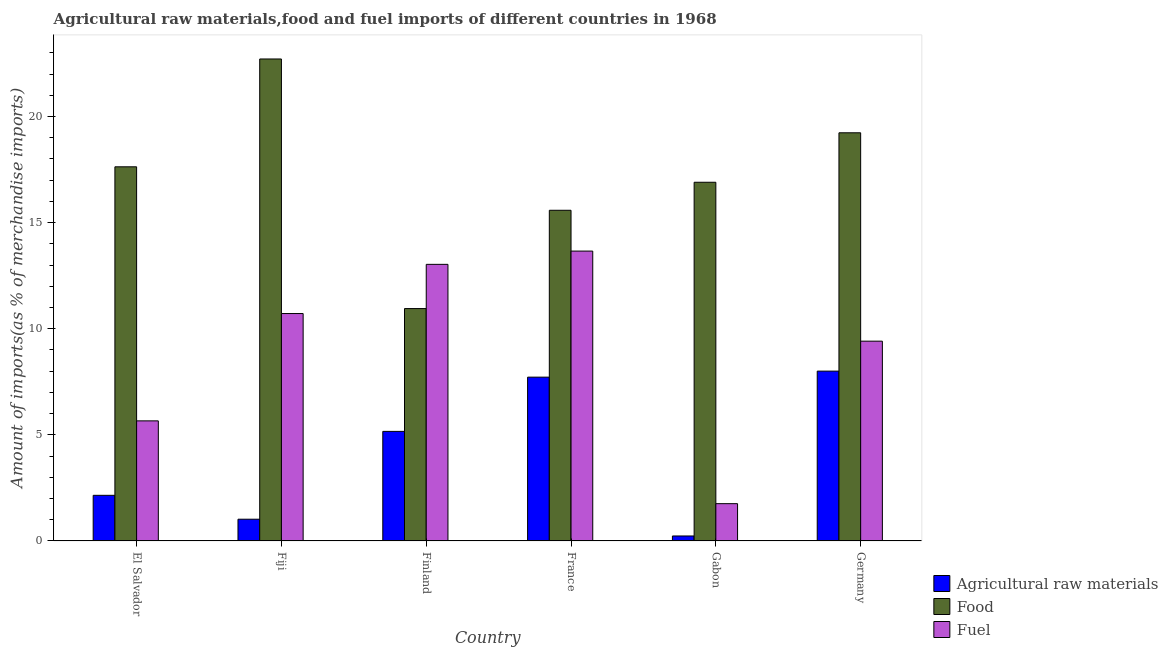How many groups of bars are there?
Offer a terse response. 6. Are the number of bars on each tick of the X-axis equal?
Your answer should be compact. Yes. What is the percentage of fuel imports in Gabon?
Give a very brief answer. 1.76. Across all countries, what is the maximum percentage of raw materials imports?
Your answer should be compact. 8. Across all countries, what is the minimum percentage of raw materials imports?
Your answer should be compact. 0.24. In which country was the percentage of raw materials imports minimum?
Give a very brief answer. Gabon. What is the total percentage of raw materials imports in the graph?
Your response must be concise. 24.3. What is the difference between the percentage of raw materials imports in Gabon and that in Germany?
Provide a succinct answer. -7.77. What is the difference between the percentage of fuel imports in Germany and the percentage of food imports in El Salvador?
Keep it short and to the point. -8.21. What is the average percentage of raw materials imports per country?
Your response must be concise. 4.05. What is the difference between the percentage of food imports and percentage of raw materials imports in France?
Your response must be concise. 7.86. What is the ratio of the percentage of food imports in France to that in Gabon?
Keep it short and to the point. 0.92. What is the difference between the highest and the second highest percentage of raw materials imports?
Your answer should be very brief. 0.28. What is the difference between the highest and the lowest percentage of raw materials imports?
Keep it short and to the point. 7.77. In how many countries, is the percentage of food imports greater than the average percentage of food imports taken over all countries?
Keep it short and to the point. 3. Is the sum of the percentage of raw materials imports in Fiji and Gabon greater than the maximum percentage of food imports across all countries?
Ensure brevity in your answer.  No. What does the 1st bar from the left in El Salvador represents?
Offer a terse response. Agricultural raw materials. What does the 1st bar from the right in Fiji represents?
Give a very brief answer. Fuel. Is it the case that in every country, the sum of the percentage of raw materials imports and percentage of food imports is greater than the percentage of fuel imports?
Your answer should be very brief. Yes. Are all the bars in the graph horizontal?
Ensure brevity in your answer.  No. What is the difference between two consecutive major ticks on the Y-axis?
Offer a terse response. 5. How are the legend labels stacked?
Your answer should be compact. Vertical. What is the title of the graph?
Your answer should be compact. Agricultural raw materials,food and fuel imports of different countries in 1968. What is the label or title of the X-axis?
Give a very brief answer. Country. What is the label or title of the Y-axis?
Your response must be concise. Amount of imports(as % of merchandise imports). What is the Amount of imports(as % of merchandise imports) of Agricultural raw materials in El Salvador?
Give a very brief answer. 2.15. What is the Amount of imports(as % of merchandise imports) in Food in El Salvador?
Give a very brief answer. 17.63. What is the Amount of imports(as % of merchandise imports) in Fuel in El Salvador?
Keep it short and to the point. 5.66. What is the Amount of imports(as % of merchandise imports) in Agricultural raw materials in Fiji?
Make the answer very short. 1.03. What is the Amount of imports(as % of merchandise imports) in Food in Fiji?
Make the answer very short. 22.71. What is the Amount of imports(as % of merchandise imports) in Fuel in Fiji?
Your answer should be compact. 10.72. What is the Amount of imports(as % of merchandise imports) of Agricultural raw materials in Finland?
Your response must be concise. 5.16. What is the Amount of imports(as % of merchandise imports) in Food in Finland?
Give a very brief answer. 10.95. What is the Amount of imports(as % of merchandise imports) in Fuel in Finland?
Your response must be concise. 13.03. What is the Amount of imports(as % of merchandise imports) of Agricultural raw materials in France?
Provide a short and direct response. 7.72. What is the Amount of imports(as % of merchandise imports) of Food in France?
Give a very brief answer. 15.58. What is the Amount of imports(as % of merchandise imports) of Fuel in France?
Offer a terse response. 13.66. What is the Amount of imports(as % of merchandise imports) of Agricultural raw materials in Gabon?
Your answer should be very brief. 0.24. What is the Amount of imports(as % of merchandise imports) in Food in Gabon?
Provide a succinct answer. 16.9. What is the Amount of imports(as % of merchandise imports) of Fuel in Gabon?
Offer a terse response. 1.76. What is the Amount of imports(as % of merchandise imports) of Agricultural raw materials in Germany?
Make the answer very short. 8. What is the Amount of imports(as % of merchandise imports) of Food in Germany?
Ensure brevity in your answer.  19.23. What is the Amount of imports(as % of merchandise imports) of Fuel in Germany?
Make the answer very short. 9.41. Across all countries, what is the maximum Amount of imports(as % of merchandise imports) in Agricultural raw materials?
Keep it short and to the point. 8. Across all countries, what is the maximum Amount of imports(as % of merchandise imports) of Food?
Provide a succinct answer. 22.71. Across all countries, what is the maximum Amount of imports(as % of merchandise imports) in Fuel?
Make the answer very short. 13.66. Across all countries, what is the minimum Amount of imports(as % of merchandise imports) in Agricultural raw materials?
Your answer should be very brief. 0.24. Across all countries, what is the minimum Amount of imports(as % of merchandise imports) of Food?
Your response must be concise. 10.95. Across all countries, what is the minimum Amount of imports(as % of merchandise imports) of Fuel?
Provide a succinct answer. 1.76. What is the total Amount of imports(as % of merchandise imports) of Agricultural raw materials in the graph?
Provide a short and direct response. 24.3. What is the total Amount of imports(as % of merchandise imports) of Food in the graph?
Your answer should be very brief. 103. What is the total Amount of imports(as % of merchandise imports) of Fuel in the graph?
Offer a terse response. 54.24. What is the difference between the Amount of imports(as % of merchandise imports) of Agricultural raw materials in El Salvador and that in Fiji?
Provide a short and direct response. 1.13. What is the difference between the Amount of imports(as % of merchandise imports) in Food in El Salvador and that in Fiji?
Give a very brief answer. -5.08. What is the difference between the Amount of imports(as % of merchandise imports) in Fuel in El Salvador and that in Fiji?
Your answer should be compact. -5.06. What is the difference between the Amount of imports(as % of merchandise imports) of Agricultural raw materials in El Salvador and that in Finland?
Your response must be concise. -3.01. What is the difference between the Amount of imports(as % of merchandise imports) of Food in El Salvador and that in Finland?
Your answer should be compact. 6.68. What is the difference between the Amount of imports(as % of merchandise imports) of Fuel in El Salvador and that in Finland?
Make the answer very short. -7.37. What is the difference between the Amount of imports(as % of merchandise imports) in Agricultural raw materials in El Salvador and that in France?
Give a very brief answer. -5.57. What is the difference between the Amount of imports(as % of merchandise imports) in Food in El Salvador and that in France?
Make the answer very short. 2.05. What is the difference between the Amount of imports(as % of merchandise imports) of Fuel in El Salvador and that in France?
Make the answer very short. -8. What is the difference between the Amount of imports(as % of merchandise imports) in Agricultural raw materials in El Salvador and that in Gabon?
Give a very brief answer. 1.92. What is the difference between the Amount of imports(as % of merchandise imports) in Food in El Salvador and that in Gabon?
Make the answer very short. 0.73. What is the difference between the Amount of imports(as % of merchandise imports) in Fuel in El Salvador and that in Gabon?
Provide a short and direct response. 3.9. What is the difference between the Amount of imports(as % of merchandise imports) in Agricultural raw materials in El Salvador and that in Germany?
Ensure brevity in your answer.  -5.85. What is the difference between the Amount of imports(as % of merchandise imports) of Food in El Salvador and that in Germany?
Your response must be concise. -1.6. What is the difference between the Amount of imports(as % of merchandise imports) of Fuel in El Salvador and that in Germany?
Offer a terse response. -3.76. What is the difference between the Amount of imports(as % of merchandise imports) of Agricultural raw materials in Fiji and that in Finland?
Offer a very short reply. -4.14. What is the difference between the Amount of imports(as % of merchandise imports) in Food in Fiji and that in Finland?
Offer a terse response. 11.76. What is the difference between the Amount of imports(as % of merchandise imports) of Fuel in Fiji and that in Finland?
Provide a succinct answer. -2.32. What is the difference between the Amount of imports(as % of merchandise imports) of Agricultural raw materials in Fiji and that in France?
Make the answer very short. -6.69. What is the difference between the Amount of imports(as % of merchandise imports) in Food in Fiji and that in France?
Provide a succinct answer. 7.13. What is the difference between the Amount of imports(as % of merchandise imports) of Fuel in Fiji and that in France?
Give a very brief answer. -2.94. What is the difference between the Amount of imports(as % of merchandise imports) of Agricultural raw materials in Fiji and that in Gabon?
Your answer should be compact. 0.79. What is the difference between the Amount of imports(as % of merchandise imports) of Food in Fiji and that in Gabon?
Provide a succinct answer. 5.81. What is the difference between the Amount of imports(as % of merchandise imports) in Fuel in Fiji and that in Gabon?
Offer a very short reply. 8.96. What is the difference between the Amount of imports(as % of merchandise imports) of Agricultural raw materials in Fiji and that in Germany?
Make the answer very short. -6.98. What is the difference between the Amount of imports(as % of merchandise imports) of Food in Fiji and that in Germany?
Your answer should be compact. 3.48. What is the difference between the Amount of imports(as % of merchandise imports) in Fuel in Fiji and that in Germany?
Your response must be concise. 1.3. What is the difference between the Amount of imports(as % of merchandise imports) of Agricultural raw materials in Finland and that in France?
Your response must be concise. -2.56. What is the difference between the Amount of imports(as % of merchandise imports) of Food in Finland and that in France?
Ensure brevity in your answer.  -4.63. What is the difference between the Amount of imports(as % of merchandise imports) of Fuel in Finland and that in France?
Provide a succinct answer. -0.62. What is the difference between the Amount of imports(as % of merchandise imports) of Agricultural raw materials in Finland and that in Gabon?
Offer a very short reply. 4.93. What is the difference between the Amount of imports(as % of merchandise imports) of Food in Finland and that in Gabon?
Provide a short and direct response. -5.95. What is the difference between the Amount of imports(as % of merchandise imports) in Fuel in Finland and that in Gabon?
Give a very brief answer. 11.28. What is the difference between the Amount of imports(as % of merchandise imports) of Agricultural raw materials in Finland and that in Germany?
Provide a short and direct response. -2.84. What is the difference between the Amount of imports(as % of merchandise imports) of Food in Finland and that in Germany?
Keep it short and to the point. -8.28. What is the difference between the Amount of imports(as % of merchandise imports) in Fuel in Finland and that in Germany?
Give a very brief answer. 3.62. What is the difference between the Amount of imports(as % of merchandise imports) of Agricultural raw materials in France and that in Gabon?
Make the answer very short. 7.48. What is the difference between the Amount of imports(as % of merchandise imports) of Food in France and that in Gabon?
Your answer should be compact. -1.32. What is the difference between the Amount of imports(as % of merchandise imports) of Agricultural raw materials in France and that in Germany?
Give a very brief answer. -0.28. What is the difference between the Amount of imports(as % of merchandise imports) in Food in France and that in Germany?
Your response must be concise. -3.65. What is the difference between the Amount of imports(as % of merchandise imports) in Fuel in France and that in Germany?
Ensure brevity in your answer.  4.24. What is the difference between the Amount of imports(as % of merchandise imports) of Agricultural raw materials in Gabon and that in Germany?
Provide a succinct answer. -7.77. What is the difference between the Amount of imports(as % of merchandise imports) of Food in Gabon and that in Germany?
Make the answer very short. -2.33. What is the difference between the Amount of imports(as % of merchandise imports) in Fuel in Gabon and that in Germany?
Your response must be concise. -7.66. What is the difference between the Amount of imports(as % of merchandise imports) in Agricultural raw materials in El Salvador and the Amount of imports(as % of merchandise imports) in Food in Fiji?
Give a very brief answer. -20.56. What is the difference between the Amount of imports(as % of merchandise imports) in Agricultural raw materials in El Salvador and the Amount of imports(as % of merchandise imports) in Fuel in Fiji?
Your answer should be compact. -8.56. What is the difference between the Amount of imports(as % of merchandise imports) in Food in El Salvador and the Amount of imports(as % of merchandise imports) in Fuel in Fiji?
Offer a very short reply. 6.91. What is the difference between the Amount of imports(as % of merchandise imports) in Agricultural raw materials in El Salvador and the Amount of imports(as % of merchandise imports) in Food in Finland?
Offer a terse response. -8.8. What is the difference between the Amount of imports(as % of merchandise imports) in Agricultural raw materials in El Salvador and the Amount of imports(as % of merchandise imports) in Fuel in Finland?
Make the answer very short. -10.88. What is the difference between the Amount of imports(as % of merchandise imports) in Food in El Salvador and the Amount of imports(as % of merchandise imports) in Fuel in Finland?
Your answer should be very brief. 4.6. What is the difference between the Amount of imports(as % of merchandise imports) in Agricultural raw materials in El Salvador and the Amount of imports(as % of merchandise imports) in Food in France?
Provide a short and direct response. -13.43. What is the difference between the Amount of imports(as % of merchandise imports) in Agricultural raw materials in El Salvador and the Amount of imports(as % of merchandise imports) in Fuel in France?
Ensure brevity in your answer.  -11.51. What is the difference between the Amount of imports(as % of merchandise imports) in Food in El Salvador and the Amount of imports(as % of merchandise imports) in Fuel in France?
Offer a very short reply. 3.97. What is the difference between the Amount of imports(as % of merchandise imports) in Agricultural raw materials in El Salvador and the Amount of imports(as % of merchandise imports) in Food in Gabon?
Make the answer very short. -14.75. What is the difference between the Amount of imports(as % of merchandise imports) in Agricultural raw materials in El Salvador and the Amount of imports(as % of merchandise imports) in Fuel in Gabon?
Provide a short and direct response. 0.39. What is the difference between the Amount of imports(as % of merchandise imports) of Food in El Salvador and the Amount of imports(as % of merchandise imports) of Fuel in Gabon?
Provide a short and direct response. 15.87. What is the difference between the Amount of imports(as % of merchandise imports) of Agricultural raw materials in El Salvador and the Amount of imports(as % of merchandise imports) of Food in Germany?
Provide a succinct answer. -17.08. What is the difference between the Amount of imports(as % of merchandise imports) in Agricultural raw materials in El Salvador and the Amount of imports(as % of merchandise imports) in Fuel in Germany?
Make the answer very short. -7.26. What is the difference between the Amount of imports(as % of merchandise imports) in Food in El Salvador and the Amount of imports(as % of merchandise imports) in Fuel in Germany?
Your answer should be very brief. 8.21. What is the difference between the Amount of imports(as % of merchandise imports) of Agricultural raw materials in Fiji and the Amount of imports(as % of merchandise imports) of Food in Finland?
Keep it short and to the point. -9.92. What is the difference between the Amount of imports(as % of merchandise imports) in Agricultural raw materials in Fiji and the Amount of imports(as % of merchandise imports) in Fuel in Finland?
Your answer should be very brief. -12.01. What is the difference between the Amount of imports(as % of merchandise imports) of Food in Fiji and the Amount of imports(as % of merchandise imports) of Fuel in Finland?
Give a very brief answer. 9.68. What is the difference between the Amount of imports(as % of merchandise imports) of Agricultural raw materials in Fiji and the Amount of imports(as % of merchandise imports) of Food in France?
Provide a succinct answer. -14.55. What is the difference between the Amount of imports(as % of merchandise imports) of Agricultural raw materials in Fiji and the Amount of imports(as % of merchandise imports) of Fuel in France?
Make the answer very short. -12.63. What is the difference between the Amount of imports(as % of merchandise imports) of Food in Fiji and the Amount of imports(as % of merchandise imports) of Fuel in France?
Give a very brief answer. 9.05. What is the difference between the Amount of imports(as % of merchandise imports) of Agricultural raw materials in Fiji and the Amount of imports(as % of merchandise imports) of Food in Gabon?
Give a very brief answer. -15.87. What is the difference between the Amount of imports(as % of merchandise imports) of Agricultural raw materials in Fiji and the Amount of imports(as % of merchandise imports) of Fuel in Gabon?
Keep it short and to the point. -0.73. What is the difference between the Amount of imports(as % of merchandise imports) in Food in Fiji and the Amount of imports(as % of merchandise imports) in Fuel in Gabon?
Offer a terse response. 20.95. What is the difference between the Amount of imports(as % of merchandise imports) of Agricultural raw materials in Fiji and the Amount of imports(as % of merchandise imports) of Food in Germany?
Your answer should be compact. -18.21. What is the difference between the Amount of imports(as % of merchandise imports) in Agricultural raw materials in Fiji and the Amount of imports(as % of merchandise imports) in Fuel in Germany?
Offer a very short reply. -8.39. What is the difference between the Amount of imports(as % of merchandise imports) in Food in Fiji and the Amount of imports(as % of merchandise imports) in Fuel in Germany?
Ensure brevity in your answer.  13.3. What is the difference between the Amount of imports(as % of merchandise imports) in Agricultural raw materials in Finland and the Amount of imports(as % of merchandise imports) in Food in France?
Your answer should be compact. -10.42. What is the difference between the Amount of imports(as % of merchandise imports) in Agricultural raw materials in Finland and the Amount of imports(as % of merchandise imports) in Fuel in France?
Ensure brevity in your answer.  -8.49. What is the difference between the Amount of imports(as % of merchandise imports) in Food in Finland and the Amount of imports(as % of merchandise imports) in Fuel in France?
Provide a succinct answer. -2.71. What is the difference between the Amount of imports(as % of merchandise imports) in Agricultural raw materials in Finland and the Amount of imports(as % of merchandise imports) in Food in Gabon?
Your answer should be very brief. -11.74. What is the difference between the Amount of imports(as % of merchandise imports) in Agricultural raw materials in Finland and the Amount of imports(as % of merchandise imports) in Fuel in Gabon?
Offer a terse response. 3.41. What is the difference between the Amount of imports(as % of merchandise imports) in Food in Finland and the Amount of imports(as % of merchandise imports) in Fuel in Gabon?
Give a very brief answer. 9.19. What is the difference between the Amount of imports(as % of merchandise imports) in Agricultural raw materials in Finland and the Amount of imports(as % of merchandise imports) in Food in Germany?
Your answer should be very brief. -14.07. What is the difference between the Amount of imports(as % of merchandise imports) in Agricultural raw materials in Finland and the Amount of imports(as % of merchandise imports) in Fuel in Germany?
Provide a short and direct response. -4.25. What is the difference between the Amount of imports(as % of merchandise imports) in Food in Finland and the Amount of imports(as % of merchandise imports) in Fuel in Germany?
Offer a terse response. 1.54. What is the difference between the Amount of imports(as % of merchandise imports) of Agricultural raw materials in France and the Amount of imports(as % of merchandise imports) of Food in Gabon?
Offer a very short reply. -9.18. What is the difference between the Amount of imports(as % of merchandise imports) of Agricultural raw materials in France and the Amount of imports(as % of merchandise imports) of Fuel in Gabon?
Provide a short and direct response. 5.96. What is the difference between the Amount of imports(as % of merchandise imports) in Food in France and the Amount of imports(as % of merchandise imports) in Fuel in Gabon?
Offer a very short reply. 13.82. What is the difference between the Amount of imports(as % of merchandise imports) of Agricultural raw materials in France and the Amount of imports(as % of merchandise imports) of Food in Germany?
Offer a very short reply. -11.51. What is the difference between the Amount of imports(as % of merchandise imports) of Agricultural raw materials in France and the Amount of imports(as % of merchandise imports) of Fuel in Germany?
Provide a short and direct response. -1.7. What is the difference between the Amount of imports(as % of merchandise imports) of Food in France and the Amount of imports(as % of merchandise imports) of Fuel in Germany?
Give a very brief answer. 6.17. What is the difference between the Amount of imports(as % of merchandise imports) in Agricultural raw materials in Gabon and the Amount of imports(as % of merchandise imports) in Food in Germany?
Offer a terse response. -19. What is the difference between the Amount of imports(as % of merchandise imports) in Agricultural raw materials in Gabon and the Amount of imports(as % of merchandise imports) in Fuel in Germany?
Provide a succinct answer. -9.18. What is the difference between the Amount of imports(as % of merchandise imports) in Food in Gabon and the Amount of imports(as % of merchandise imports) in Fuel in Germany?
Offer a terse response. 7.49. What is the average Amount of imports(as % of merchandise imports) of Agricultural raw materials per country?
Offer a very short reply. 4.05. What is the average Amount of imports(as % of merchandise imports) of Food per country?
Provide a short and direct response. 17.17. What is the average Amount of imports(as % of merchandise imports) in Fuel per country?
Give a very brief answer. 9.04. What is the difference between the Amount of imports(as % of merchandise imports) in Agricultural raw materials and Amount of imports(as % of merchandise imports) in Food in El Salvador?
Your response must be concise. -15.48. What is the difference between the Amount of imports(as % of merchandise imports) in Agricultural raw materials and Amount of imports(as % of merchandise imports) in Fuel in El Salvador?
Your answer should be compact. -3.51. What is the difference between the Amount of imports(as % of merchandise imports) in Food and Amount of imports(as % of merchandise imports) in Fuel in El Salvador?
Ensure brevity in your answer.  11.97. What is the difference between the Amount of imports(as % of merchandise imports) in Agricultural raw materials and Amount of imports(as % of merchandise imports) in Food in Fiji?
Keep it short and to the point. -21.68. What is the difference between the Amount of imports(as % of merchandise imports) of Agricultural raw materials and Amount of imports(as % of merchandise imports) of Fuel in Fiji?
Offer a very short reply. -9.69. What is the difference between the Amount of imports(as % of merchandise imports) of Food and Amount of imports(as % of merchandise imports) of Fuel in Fiji?
Your response must be concise. 11.99. What is the difference between the Amount of imports(as % of merchandise imports) in Agricultural raw materials and Amount of imports(as % of merchandise imports) in Food in Finland?
Keep it short and to the point. -5.79. What is the difference between the Amount of imports(as % of merchandise imports) of Agricultural raw materials and Amount of imports(as % of merchandise imports) of Fuel in Finland?
Make the answer very short. -7.87. What is the difference between the Amount of imports(as % of merchandise imports) of Food and Amount of imports(as % of merchandise imports) of Fuel in Finland?
Offer a terse response. -2.08. What is the difference between the Amount of imports(as % of merchandise imports) in Agricultural raw materials and Amount of imports(as % of merchandise imports) in Food in France?
Offer a very short reply. -7.86. What is the difference between the Amount of imports(as % of merchandise imports) in Agricultural raw materials and Amount of imports(as % of merchandise imports) in Fuel in France?
Offer a very short reply. -5.94. What is the difference between the Amount of imports(as % of merchandise imports) in Food and Amount of imports(as % of merchandise imports) in Fuel in France?
Keep it short and to the point. 1.92. What is the difference between the Amount of imports(as % of merchandise imports) in Agricultural raw materials and Amount of imports(as % of merchandise imports) in Food in Gabon?
Offer a terse response. -16.66. What is the difference between the Amount of imports(as % of merchandise imports) in Agricultural raw materials and Amount of imports(as % of merchandise imports) in Fuel in Gabon?
Keep it short and to the point. -1.52. What is the difference between the Amount of imports(as % of merchandise imports) in Food and Amount of imports(as % of merchandise imports) in Fuel in Gabon?
Give a very brief answer. 15.14. What is the difference between the Amount of imports(as % of merchandise imports) in Agricultural raw materials and Amount of imports(as % of merchandise imports) in Food in Germany?
Provide a succinct answer. -11.23. What is the difference between the Amount of imports(as % of merchandise imports) in Agricultural raw materials and Amount of imports(as % of merchandise imports) in Fuel in Germany?
Ensure brevity in your answer.  -1.41. What is the difference between the Amount of imports(as % of merchandise imports) of Food and Amount of imports(as % of merchandise imports) of Fuel in Germany?
Your response must be concise. 9.82. What is the ratio of the Amount of imports(as % of merchandise imports) in Agricultural raw materials in El Salvador to that in Fiji?
Your response must be concise. 2.1. What is the ratio of the Amount of imports(as % of merchandise imports) in Food in El Salvador to that in Fiji?
Make the answer very short. 0.78. What is the ratio of the Amount of imports(as % of merchandise imports) in Fuel in El Salvador to that in Fiji?
Offer a terse response. 0.53. What is the ratio of the Amount of imports(as % of merchandise imports) of Agricultural raw materials in El Salvador to that in Finland?
Your answer should be compact. 0.42. What is the ratio of the Amount of imports(as % of merchandise imports) in Food in El Salvador to that in Finland?
Give a very brief answer. 1.61. What is the ratio of the Amount of imports(as % of merchandise imports) of Fuel in El Salvador to that in Finland?
Provide a short and direct response. 0.43. What is the ratio of the Amount of imports(as % of merchandise imports) of Agricultural raw materials in El Salvador to that in France?
Your response must be concise. 0.28. What is the ratio of the Amount of imports(as % of merchandise imports) of Food in El Salvador to that in France?
Ensure brevity in your answer.  1.13. What is the ratio of the Amount of imports(as % of merchandise imports) in Fuel in El Salvador to that in France?
Offer a terse response. 0.41. What is the ratio of the Amount of imports(as % of merchandise imports) in Agricultural raw materials in El Salvador to that in Gabon?
Offer a terse response. 9.12. What is the ratio of the Amount of imports(as % of merchandise imports) in Food in El Salvador to that in Gabon?
Provide a succinct answer. 1.04. What is the ratio of the Amount of imports(as % of merchandise imports) in Fuel in El Salvador to that in Gabon?
Your response must be concise. 3.22. What is the ratio of the Amount of imports(as % of merchandise imports) of Agricultural raw materials in El Salvador to that in Germany?
Give a very brief answer. 0.27. What is the ratio of the Amount of imports(as % of merchandise imports) in Fuel in El Salvador to that in Germany?
Give a very brief answer. 0.6. What is the ratio of the Amount of imports(as % of merchandise imports) in Agricultural raw materials in Fiji to that in Finland?
Provide a succinct answer. 0.2. What is the ratio of the Amount of imports(as % of merchandise imports) in Food in Fiji to that in Finland?
Provide a short and direct response. 2.07. What is the ratio of the Amount of imports(as % of merchandise imports) of Fuel in Fiji to that in Finland?
Your answer should be compact. 0.82. What is the ratio of the Amount of imports(as % of merchandise imports) in Agricultural raw materials in Fiji to that in France?
Your answer should be compact. 0.13. What is the ratio of the Amount of imports(as % of merchandise imports) in Food in Fiji to that in France?
Provide a succinct answer. 1.46. What is the ratio of the Amount of imports(as % of merchandise imports) in Fuel in Fiji to that in France?
Your answer should be compact. 0.78. What is the ratio of the Amount of imports(as % of merchandise imports) of Agricultural raw materials in Fiji to that in Gabon?
Your answer should be very brief. 4.35. What is the ratio of the Amount of imports(as % of merchandise imports) in Food in Fiji to that in Gabon?
Ensure brevity in your answer.  1.34. What is the ratio of the Amount of imports(as % of merchandise imports) in Fuel in Fiji to that in Gabon?
Provide a succinct answer. 6.1. What is the ratio of the Amount of imports(as % of merchandise imports) in Agricultural raw materials in Fiji to that in Germany?
Your response must be concise. 0.13. What is the ratio of the Amount of imports(as % of merchandise imports) in Food in Fiji to that in Germany?
Your answer should be compact. 1.18. What is the ratio of the Amount of imports(as % of merchandise imports) of Fuel in Fiji to that in Germany?
Keep it short and to the point. 1.14. What is the ratio of the Amount of imports(as % of merchandise imports) in Agricultural raw materials in Finland to that in France?
Give a very brief answer. 0.67. What is the ratio of the Amount of imports(as % of merchandise imports) in Food in Finland to that in France?
Make the answer very short. 0.7. What is the ratio of the Amount of imports(as % of merchandise imports) in Fuel in Finland to that in France?
Ensure brevity in your answer.  0.95. What is the ratio of the Amount of imports(as % of merchandise imports) of Agricultural raw materials in Finland to that in Gabon?
Offer a very short reply. 21.88. What is the ratio of the Amount of imports(as % of merchandise imports) in Food in Finland to that in Gabon?
Make the answer very short. 0.65. What is the ratio of the Amount of imports(as % of merchandise imports) in Fuel in Finland to that in Gabon?
Your answer should be very brief. 7.41. What is the ratio of the Amount of imports(as % of merchandise imports) of Agricultural raw materials in Finland to that in Germany?
Provide a succinct answer. 0.65. What is the ratio of the Amount of imports(as % of merchandise imports) in Food in Finland to that in Germany?
Provide a succinct answer. 0.57. What is the ratio of the Amount of imports(as % of merchandise imports) in Fuel in Finland to that in Germany?
Your answer should be very brief. 1.38. What is the ratio of the Amount of imports(as % of merchandise imports) in Agricultural raw materials in France to that in Gabon?
Your answer should be very brief. 32.71. What is the ratio of the Amount of imports(as % of merchandise imports) in Food in France to that in Gabon?
Provide a short and direct response. 0.92. What is the ratio of the Amount of imports(as % of merchandise imports) of Fuel in France to that in Gabon?
Ensure brevity in your answer.  7.77. What is the ratio of the Amount of imports(as % of merchandise imports) in Agricultural raw materials in France to that in Germany?
Make the answer very short. 0.96. What is the ratio of the Amount of imports(as % of merchandise imports) in Food in France to that in Germany?
Make the answer very short. 0.81. What is the ratio of the Amount of imports(as % of merchandise imports) of Fuel in France to that in Germany?
Offer a terse response. 1.45. What is the ratio of the Amount of imports(as % of merchandise imports) of Agricultural raw materials in Gabon to that in Germany?
Make the answer very short. 0.03. What is the ratio of the Amount of imports(as % of merchandise imports) in Food in Gabon to that in Germany?
Make the answer very short. 0.88. What is the ratio of the Amount of imports(as % of merchandise imports) of Fuel in Gabon to that in Germany?
Your response must be concise. 0.19. What is the difference between the highest and the second highest Amount of imports(as % of merchandise imports) of Agricultural raw materials?
Offer a very short reply. 0.28. What is the difference between the highest and the second highest Amount of imports(as % of merchandise imports) in Food?
Ensure brevity in your answer.  3.48. What is the difference between the highest and the second highest Amount of imports(as % of merchandise imports) of Fuel?
Offer a very short reply. 0.62. What is the difference between the highest and the lowest Amount of imports(as % of merchandise imports) of Agricultural raw materials?
Offer a very short reply. 7.77. What is the difference between the highest and the lowest Amount of imports(as % of merchandise imports) of Food?
Provide a short and direct response. 11.76. 